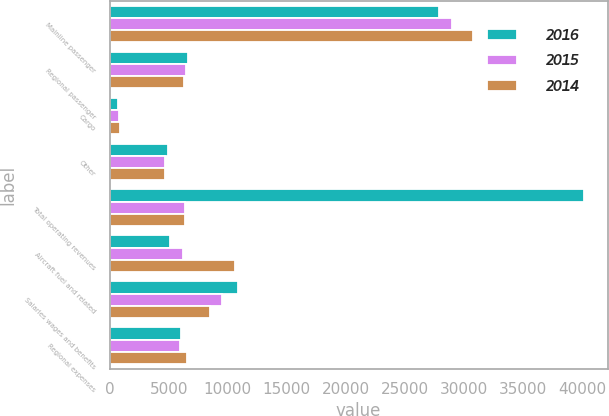<chart> <loc_0><loc_0><loc_500><loc_500><stacked_bar_chart><ecel><fcel>Mainline passenger<fcel>Regional passenger<fcel>Cargo<fcel>Other<fcel>Total operating revenues<fcel>Aircraft fuel and related<fcel>Salaries wages and benefits<fcel>Regional expenses<nl><fcel>2016<fcel>27909<fcel>6670<fcel>700<fcel>4901<fcel>40180<fcel>5071<fcel>10890<fcel>6044<nl><fcel>2015<fcel>29037<fcel>6475<fcel>760<fcel>4718<fcel>6398.5<fcel>6226<fcel>9524<fcel>5983<nl><fcel>2014<fcel>30802<fcel>6322<fcel>875<fcel>4651<fcel>6398.5<fcel>10592<fcel>8508<fcel>6516<nl></chart> 